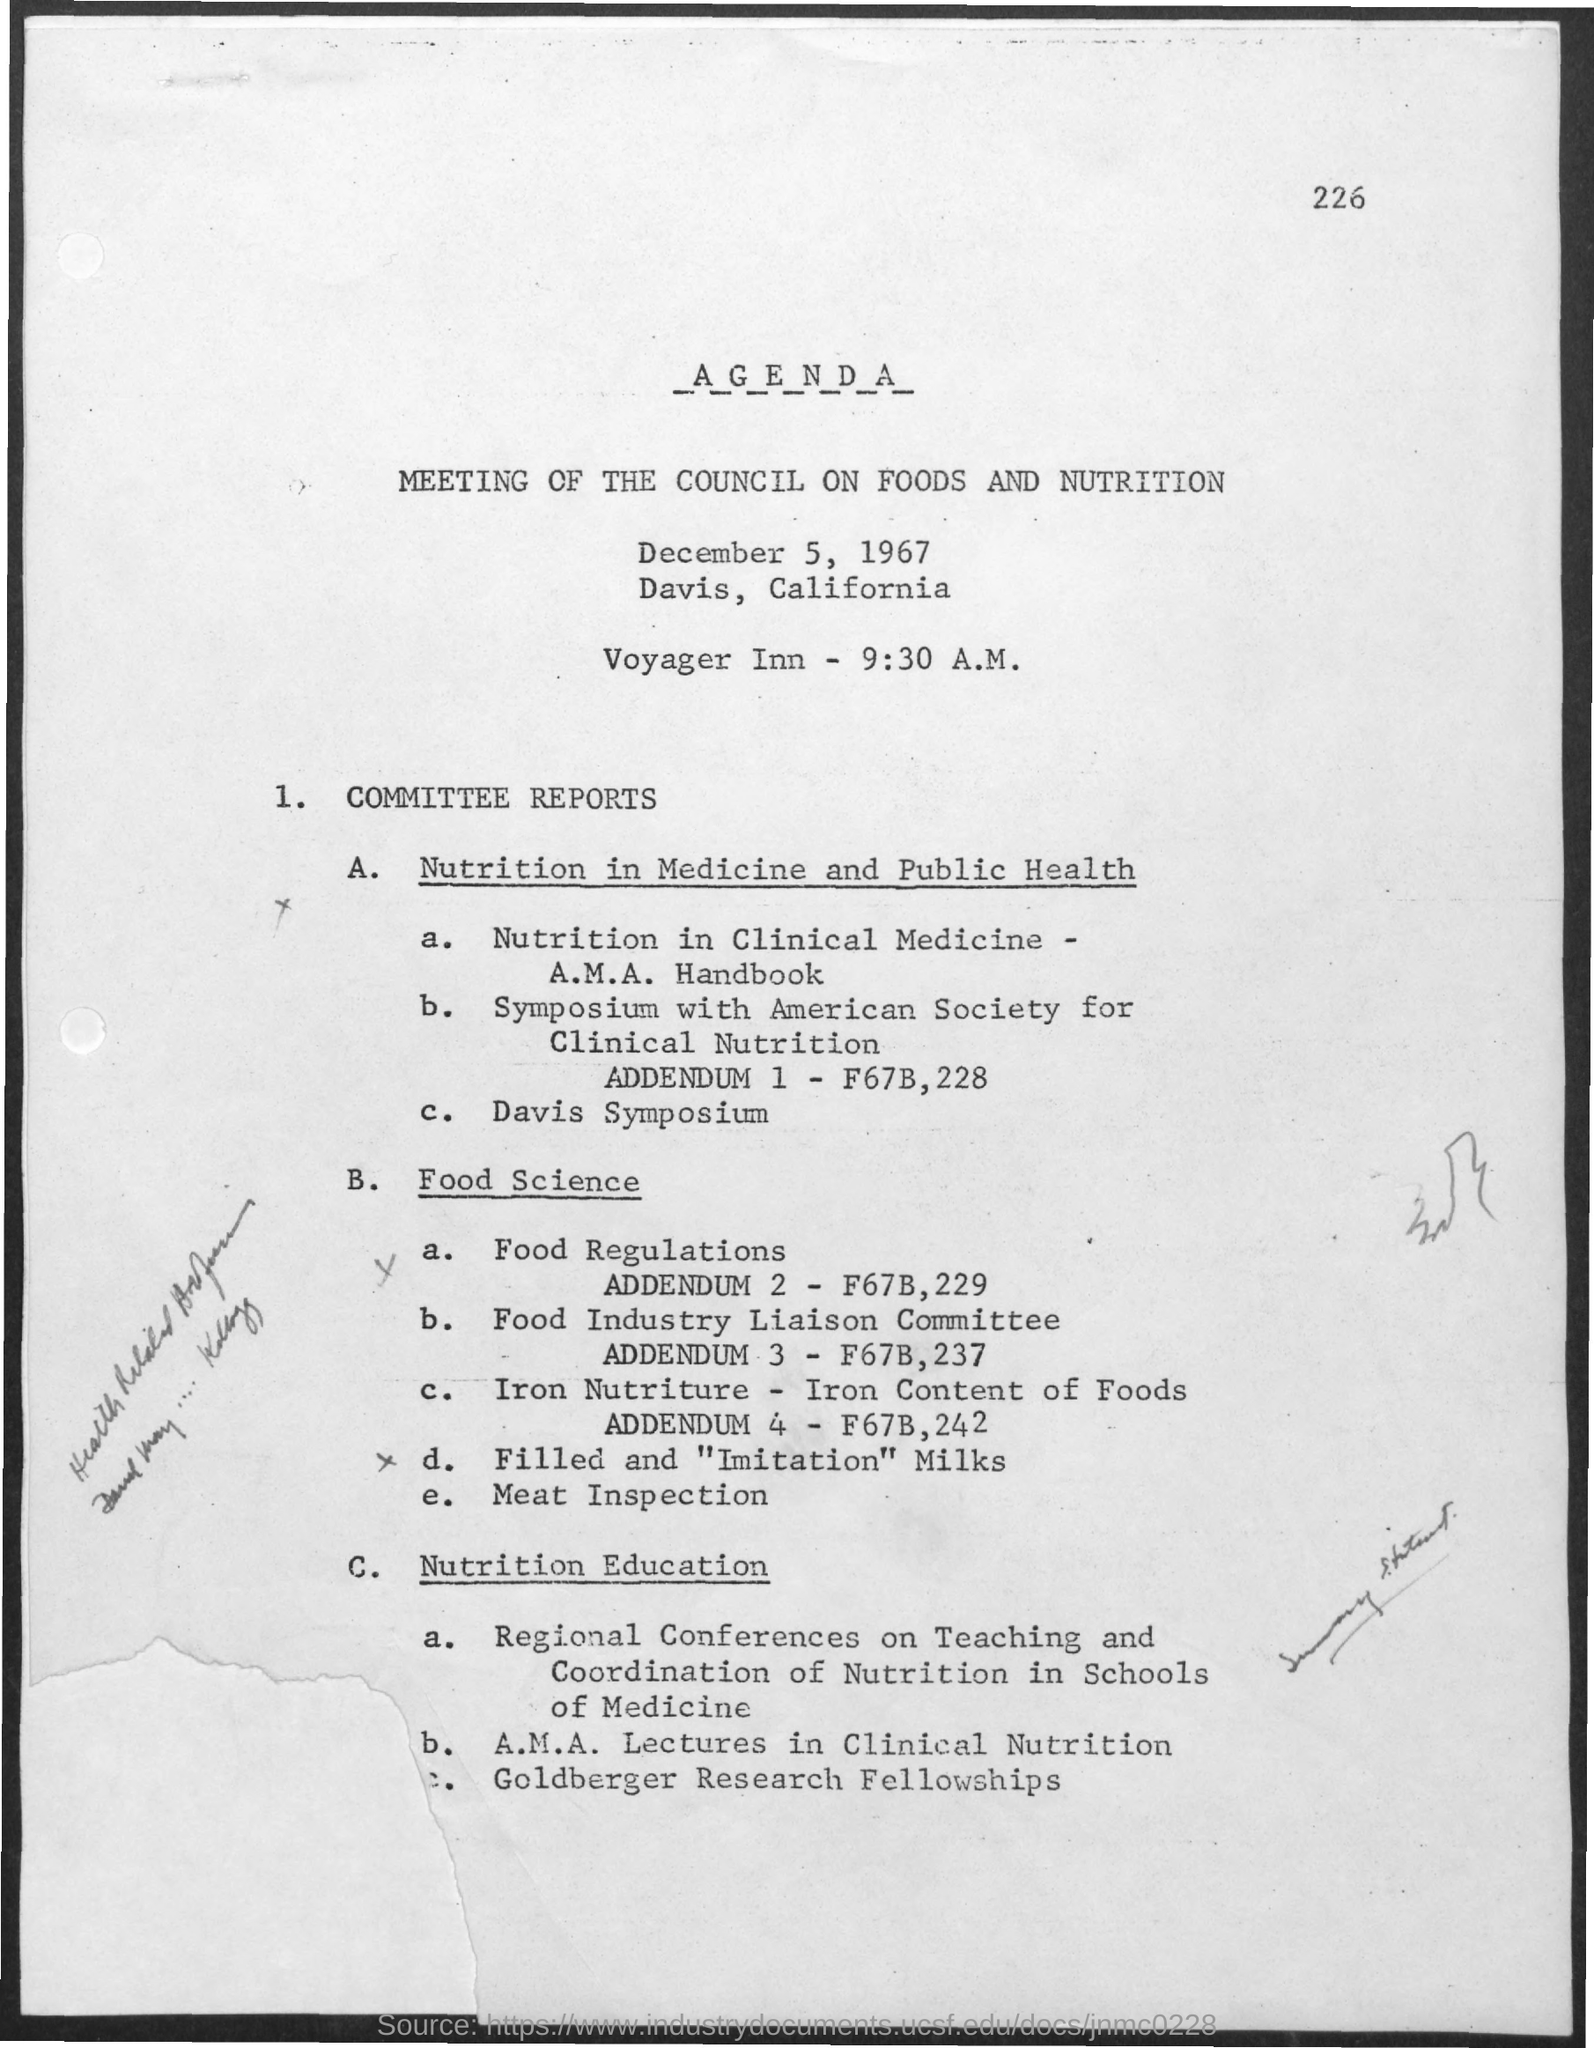What is the page number?
Your answer should be very brief. 226. What is the first title in the document?
Provide a short and direct response. Agenda. What is the second title in the document?
Your response must be concise. Meeting of the council on foods and nutrition. What is the date mentioned in the document?
Your answer should be very brief. December 5, 1967. What is the time mentioned in the document?
Your answer should be very brief. 9:30 a.m. What is the agenda number 1?
Provide a succinct answer. Committee reports. 